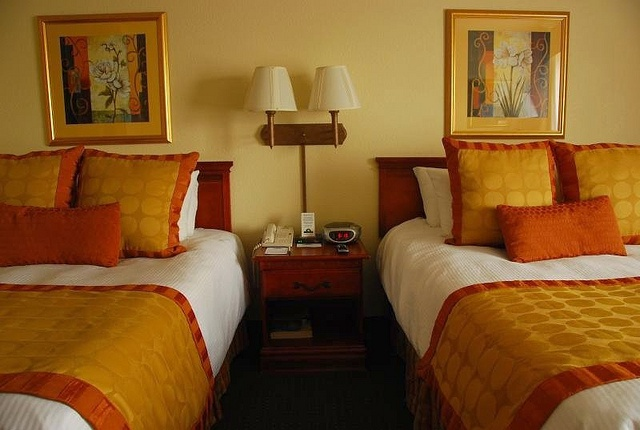Describe the objects in this image and their specific colors. I can see bed in olive, brown, and maroon tones, bed in olive and maroon tones, book in black, maroon, and olive tones, clock in olive, black, maroon, brown, and gray tones, and remote in olive, black, and gray tones in this image. 